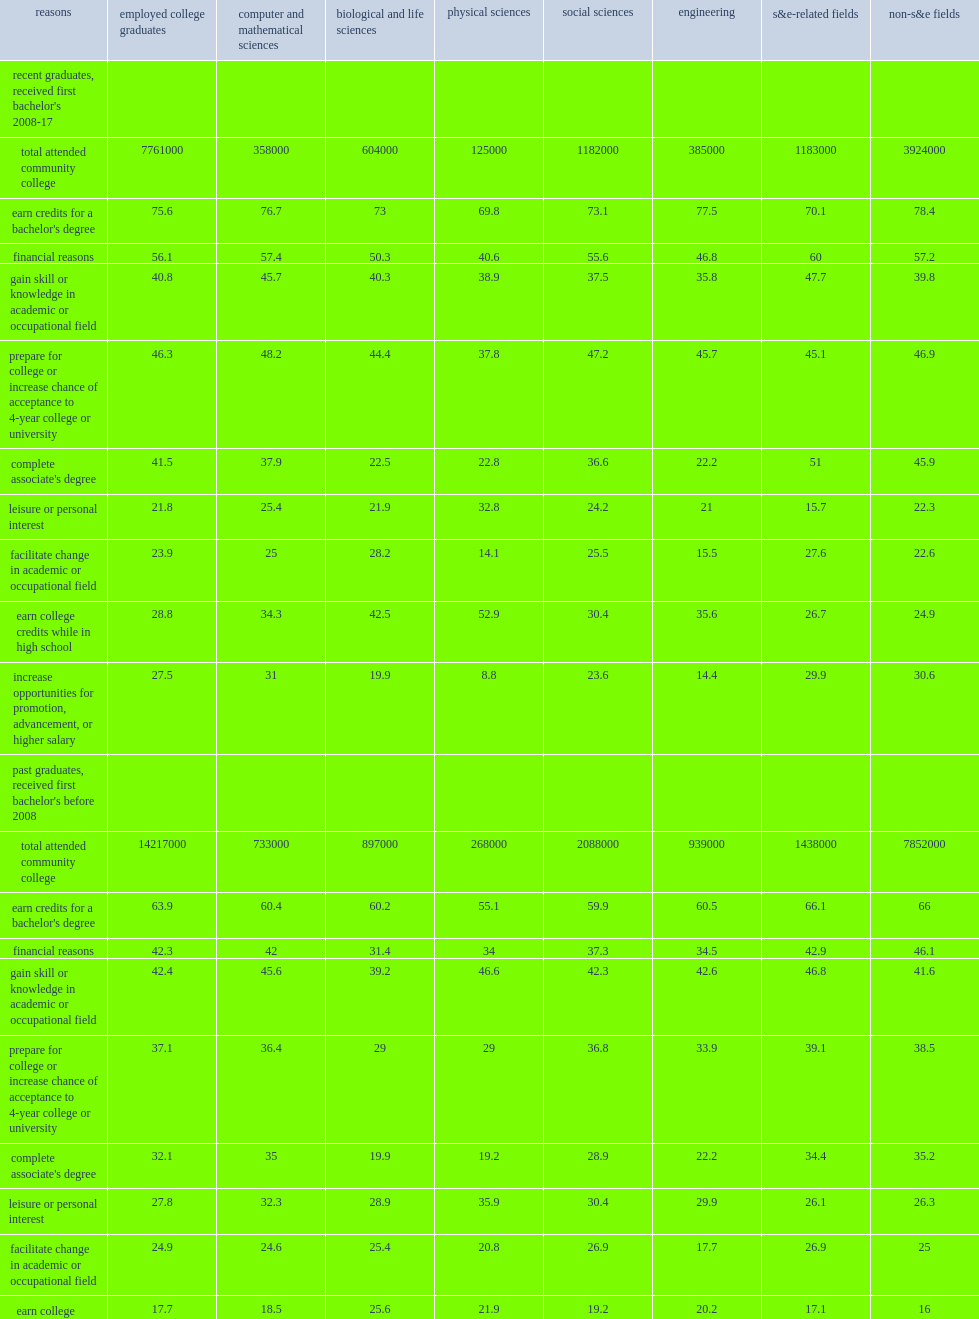Which reason was the most frequently cited reason for attending a community college? Earn credits for a bachelor's degree. What was the percentage points of recent graduates reported "to complete an associate's degree" as a reason for attending community college? 41.5. 